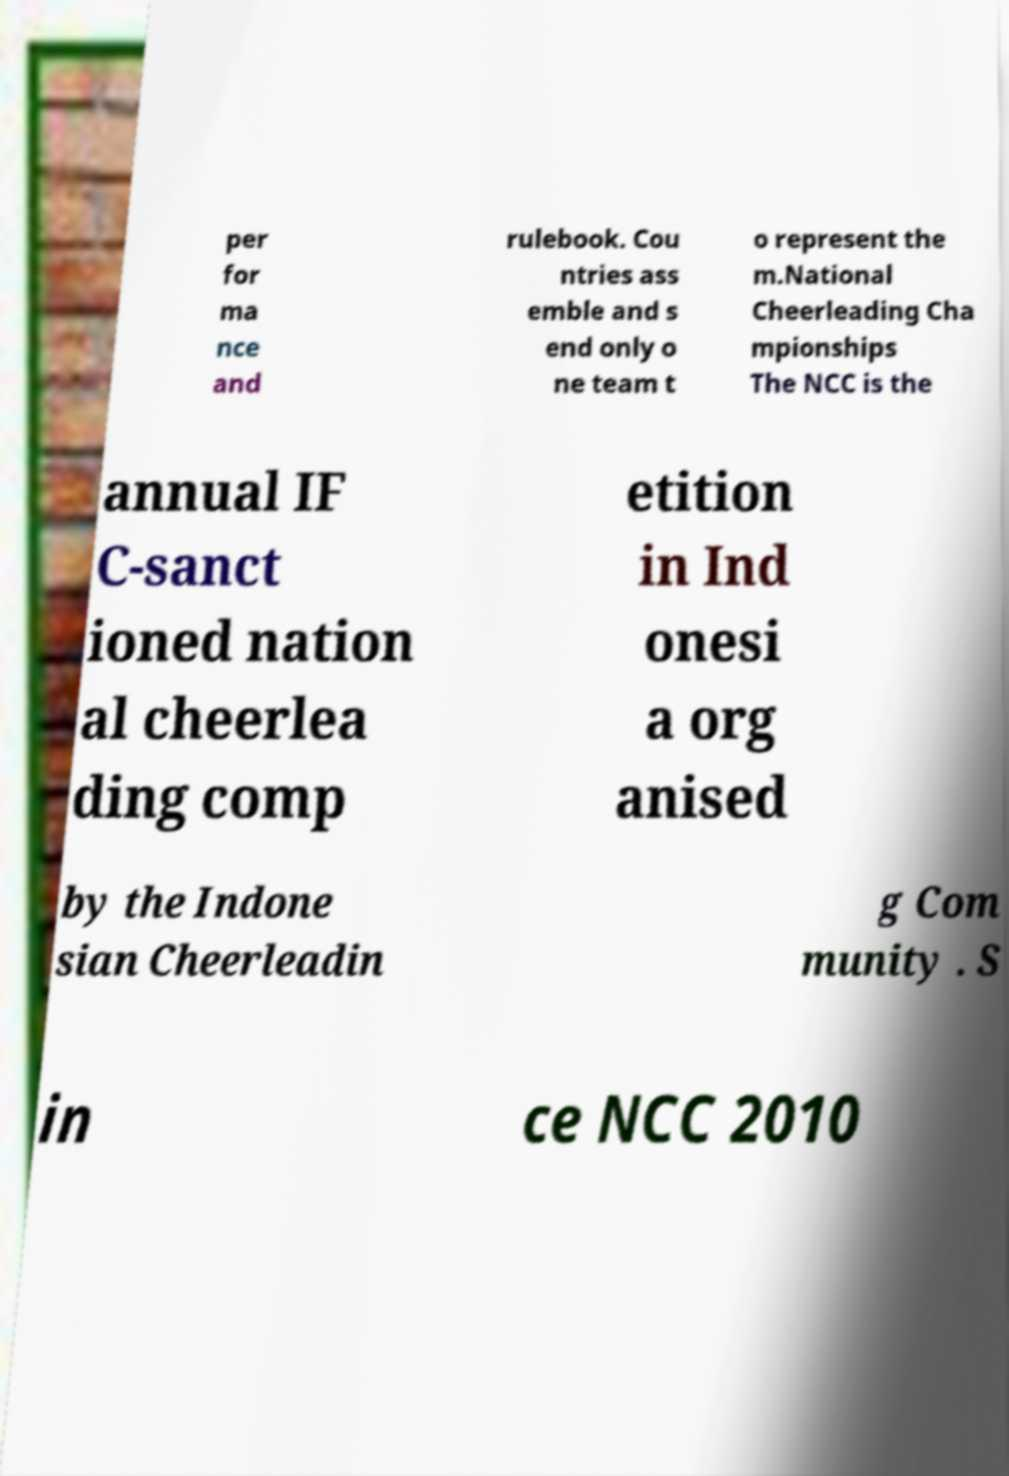Can you accurately transcribe the text from the provided image for me? per for ma nce and rulebook. Cou ntries ass emble and s end only o ne team t o represent the m.National Cheerleading Cha mpionships The NCC is the annual IF C-sanct ioned nation al cheerlea ding comp etition in Ind onesi a org anised by the Indone sian Cheerleadin g Com munity . S in ce NCC 2010 